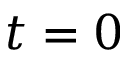Convert formula to latex. <formula><loc_0><loc_0><loc_500><loc_500>t = 0</formula> 